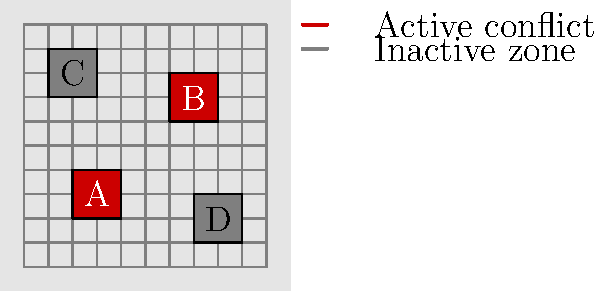Based on the satellite imagery analysis shown in the grid, which two areas are identified as active conflict hotspots? To answer this question, we need to analyze the satellite imagery representation provided in the grid. Let's break down the information:

1. The grid is divided into 10x10 cells, representing a satellite image of a region.
2. There are four marked areas on the grid, labeled A, B, C, and D.
3. The legend indicates that red-filled squares represent active conflict zones, while gray-filled squares represent inactive zones.

Now, let's examine each area:

1. Area A (coordinates 2-4 on both x and y axes): This area is filled with red, indicating an active conflict hotspot.
2. Area B (coordinates 6-8 on both x and y axes): This area is also filled with red, indicating another active conflict hotspot.
3. Area C (coordinates 1-3 on x-axis, 7-9 on y-axis): This area is filled with gray, indicating an inactive zone.
4. Area D (coordinates 7-9 on x-axis, 1-3 on y-axis): This area is also filled with gray, indicating another inactive zone.

Based on this analysis, we can conclude that the two areas identified as active conflict hotspots are A and B.
Answer: A and B 